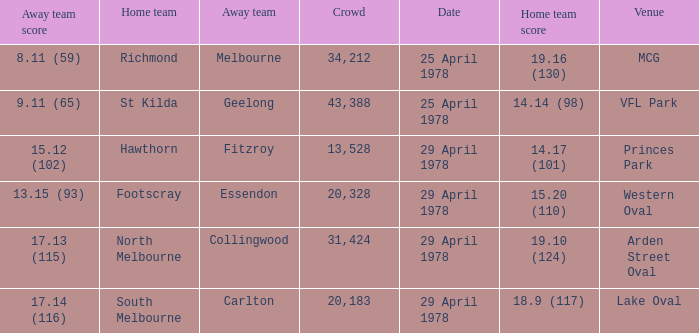What was the away team that played at Princes Park? Fitzroy. 